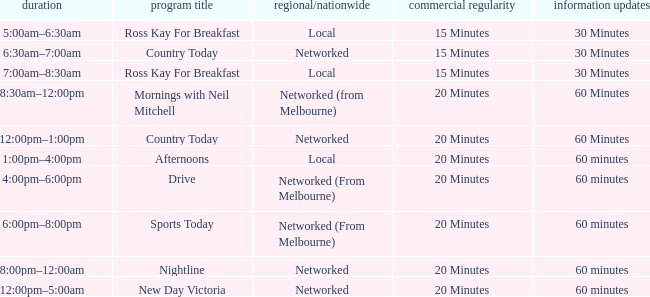What News Freq has a Time of 1:00pm–4:00pm? 60 minutes. 